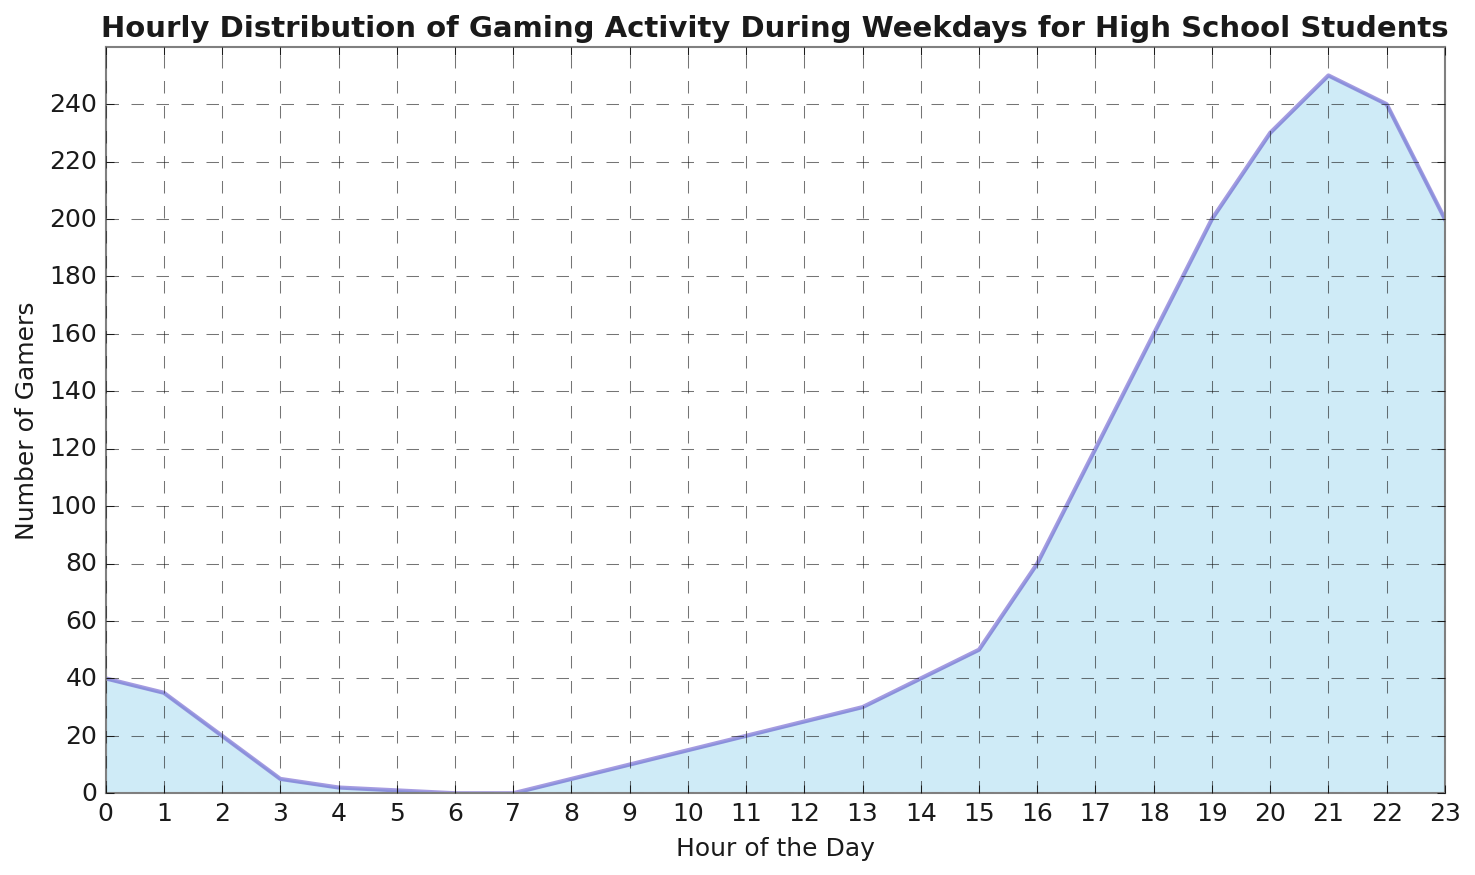What time has the highest number of gamers? The highest point in the chart is at 21:00 where the number of gamers is 250. Hence, the time with the highest number of gamers is 21:00.
Answer: 21:00 How many gamers are there between 18:00 and 21:00 in total? To find the total number of gamers between 18:00 and 21:00, sum the number of gamers at each hour: 160 (18:00) + 200 (19:00) + 230 (20:00) + 250 (21:00) = 840.
Answer: 840 At what hours are there exactly 0 gamers? To determine the hours with no gamers, observe that the number of gamers at 06:00 and 07:00 is zero.
Answer: 06:00, 07:00 How does the number of gamers change from 03:00 to 06:00? Observe the number of gamers at each hour: it starts at 5 (03:00), drops to 2 (04:00), drops further to 1 (05:00), and finally reaches 0 (06:00). So, the number of gamers steadily decreases.
Answer: Steadily decreases Which times during the day do the gamers increase the fastest? Examine the steepest increase in the chart. The number of gamers significantly rises from 120 (17:00) to 160 (18:00) and again from 160 (18:00) to 200 (19:00), and finally from 200 (19:00) to 230 (20:00). The most rapid increase occurs during these hours.
Answer: 17:00 to 20:00 During which hour is there a sudden drop in the number of gamers? Identify the steepest decline in the chart, which occurs from 22:00 to 23:00 where the number of gamers drops from 240 to 200.
Answer: 22:00 to 23:00 What's the average number of gamers between 15:00 and 18:00? Calculate the average by adding the number of gamers at each hour and divide by the number of hours: (50 (15:00) + 80 (16:00) + 120 (17:00) + 160 (18:00)) / 4 = 410 / 4 = 102.5.
Answer: 102.5 Compare the number of gamers at 12:00 and 16:00. At 12:00, there are 25 gamers, whereas at 16:00, there are 80 gamers. Therefore, the number of gamers is greater at 16:00.
Answer: 16:00 What's the total number of gamers from 22:00 to 23:00? To find the total number of gamers from 22:00 to 23:00, sum the number of gamers at each hour: 240 (22:00) + 200 (23:00) = 440.
Answer: 440 